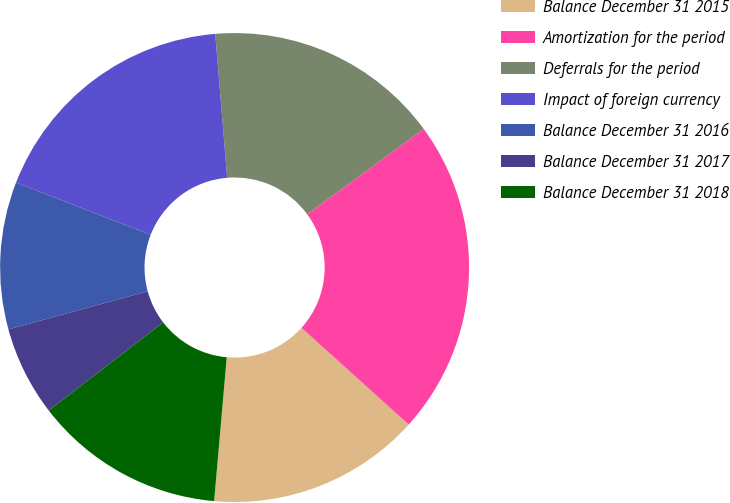Convert chart to OTSL. <chart><loc_0><loc_0><loc_500><loc_500><pie_chart><fcel>Balance December 31 2015<fcel>Amortization for the period<fcel>Deferrals for the period<fcel>Impact of foreign currency<fcel>Balance December 31 2016<fcel>Balance December 31 2017<fcel>Balance December 31 2018<nl><fcel>14.71%<fcel>21.74%<fcel>16.25%<fcel>17.78%<fcel>10.15%<fcel>6.19%<fcel>13.17%<nl></chart> 